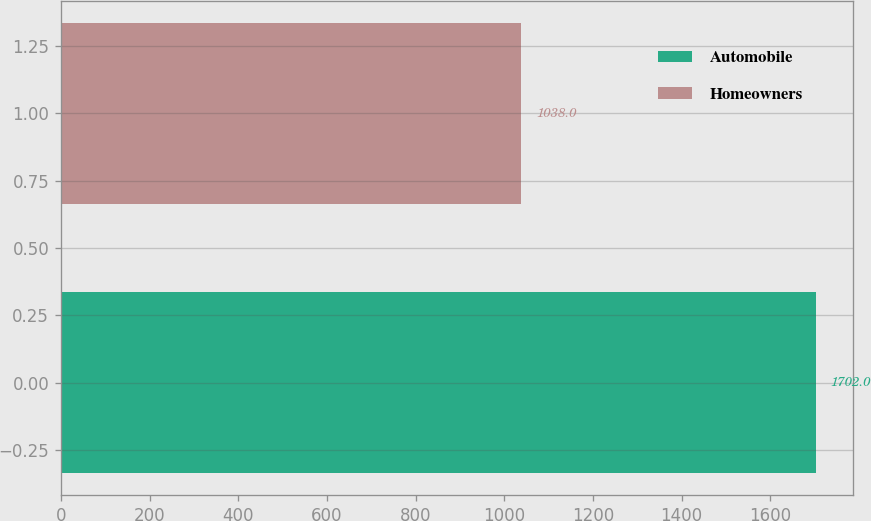<chart> <loc_0><loc_0><loc_500><loc_500><bar_chart><fcel>Automobile<fcel>Homeowners<nl><fcel>1702<fcel>1038<nl></chart> 